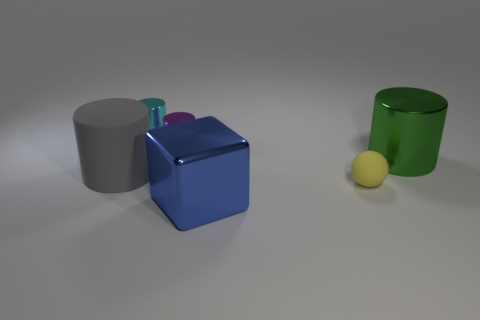Does the large gray matte object have the same shape as the large thing that is to the right of the blue thing?
Offer a very short reply. Yes. How many objects are either big cylinders to the right of the tiny rubber sphere or tiny objects in front of the cyan object?
Your answer should be compact. 3. What is the material of the small yellow sphere?
Keep it short and to the point. Rubber. What is the size of the matte thing in front of the gray matte cylinder?
Offer a very short reply. Small. The large cylinder that is right of the tiny thing that is in front of the cylinder that is to the right of the purple cylinder is made of what material?
Keep it short and to the point. Metal. Is the large gray rubber thing the same shape as the blue object?
Your answer should be compact. No. How many metal objects are either large blue blocks or small purple cylinders?
Provide a short and direct response. 2. How many tiny things are there?
Provide a short and direct response. 3. There is a cylinder that is the same size as the cyan object; what color is it?
Ensure brevity in your answer.  Purple. Do the blue metallic thing and the yellow object have the same size?
Provide a short and direct response. No. 